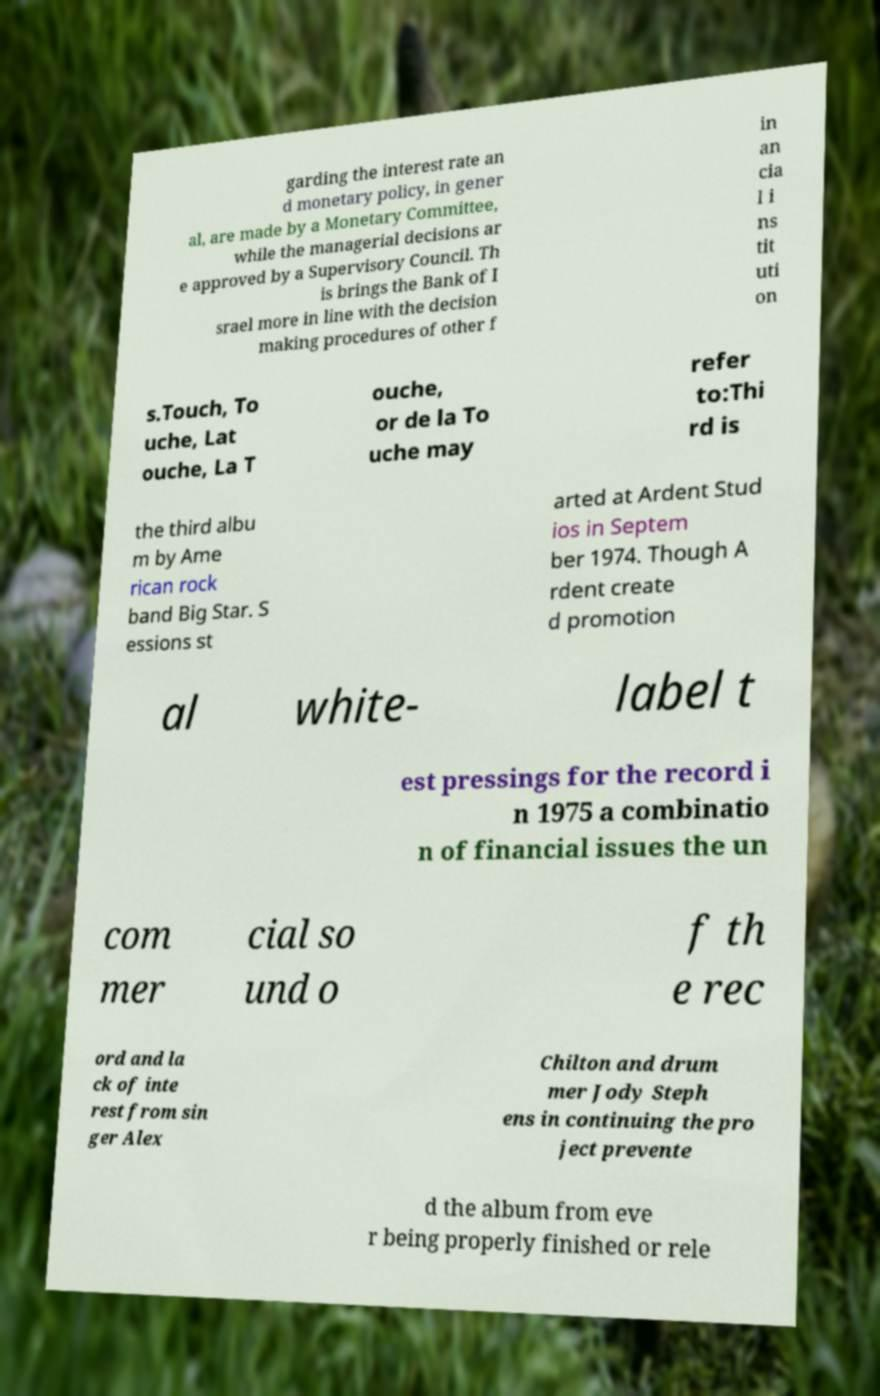For documentation purposes, I need the text within this image transcribed. Could you provide that? garding the interest rate an d monetary policy, in gener al, are made by a Monetary Committee, while the managerial decisions ar e approved by a Supervisory Council. Th is brings the Bank of I srael more in line with the decision making procedures of other f in an cia l i ns tit uti on s.Touch, To uche, Lat ouche, La T ouche, or de la To uche may refer to:Thi rd is the third albu m by Ame rican rock band Big Star. S essions st arted at Ardent Stud ios in Septem ber 1974. Though A rdent create d promotion al white- label t est pressings for the record i n 1975 a combinatio n of financial issues the un com mer cial so und o f th e rec ord and la ck of inte rest from sin ger Alex Chilton and drum mer Jody Steph ens in continuing the pro ject prevente d the album from eve r being properly finished or rele 